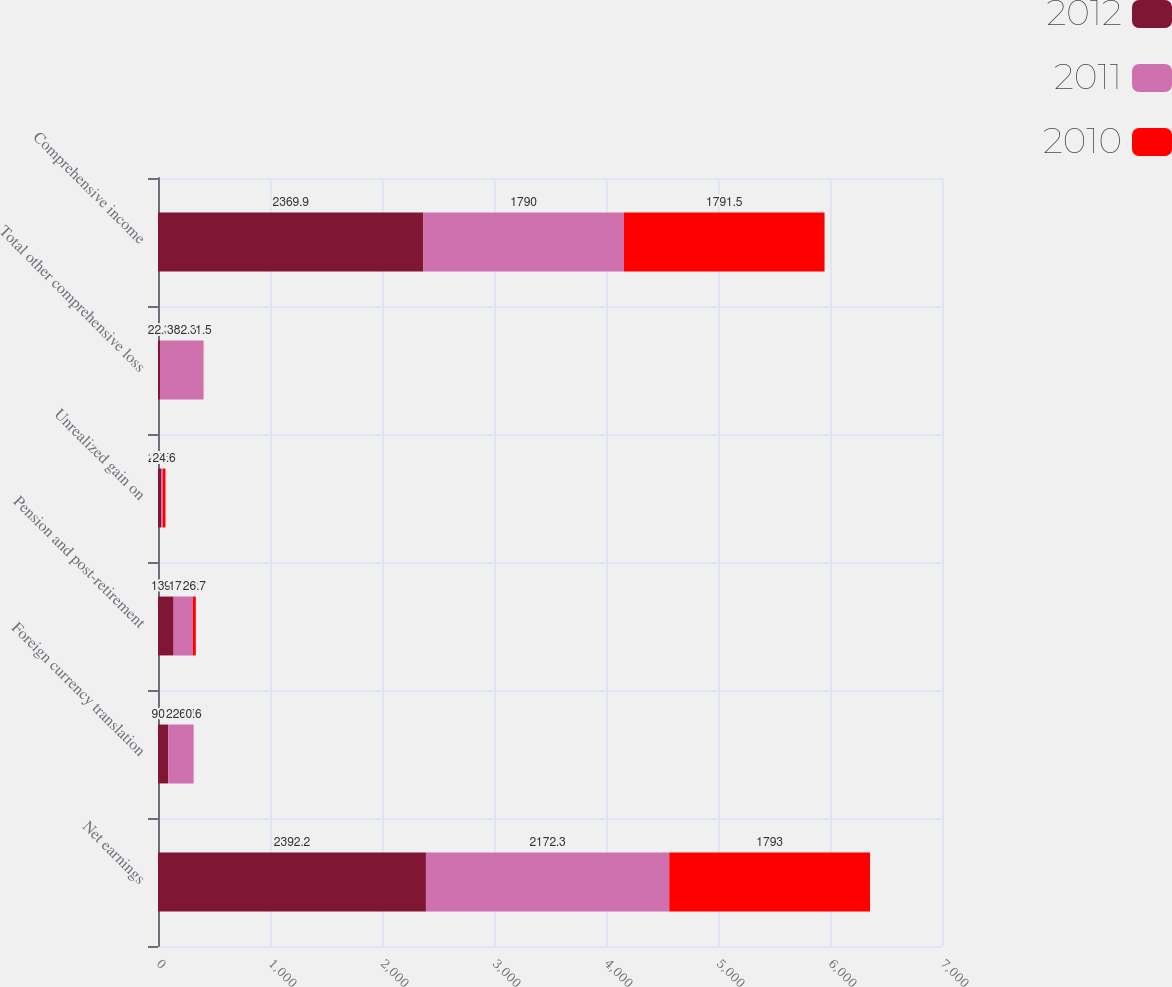<chart> <loc_0><loc_0><loc_500><loc_500><stacked_bar_chart><ecel><fcel>Net earnings<fcel>Foreign currency translation<fcel>Pension and post-retirement<fcel>Unrealized gain on<fcel>Total other comprehensive loss<fcel>Comprehensive income<nl><fcel>2012<fcel>2392.2<fcel>90.8<fcel>139.7<fcel>26.6<fcel>22.3<fcel>2369.9<nl><fcel>2011<fcel>2172.3<fcel>226.8<fcel>171.2<fcel>15.7<fcel>382.3<fcel>1790<nl><fcel>2010<fcel>1793<fcel>0.6<fcel>26.7<fcel>24.6<fcel>1.5<fcel>1791.5<nl></chart> 